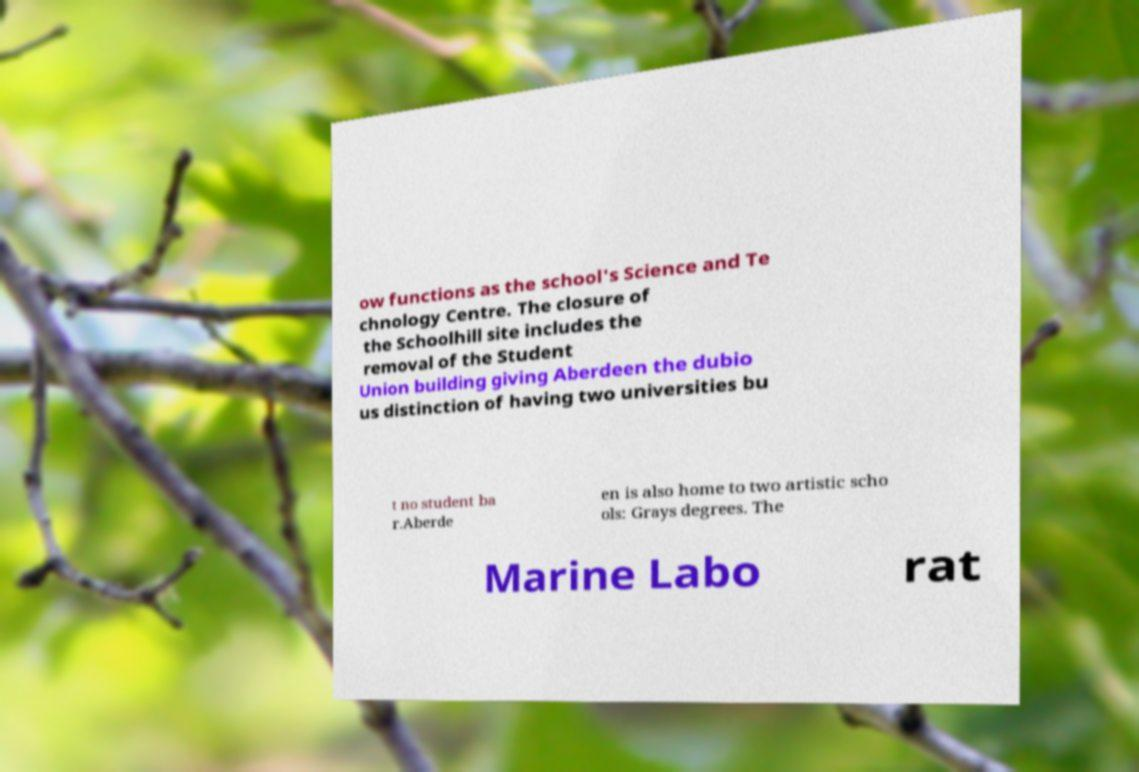I need the written content from this picture converted into text. Can you do that? ow functions as the school's Science and Te chnology Centre. The closure of the Schoolhill site includes the removal of the Student Union building giving Aberdeen the dubio us distinction of having two universities bu t no student ba r.Aberde en is also home to two artistic scho ols: Grays degrees. The Marine Labo rat 